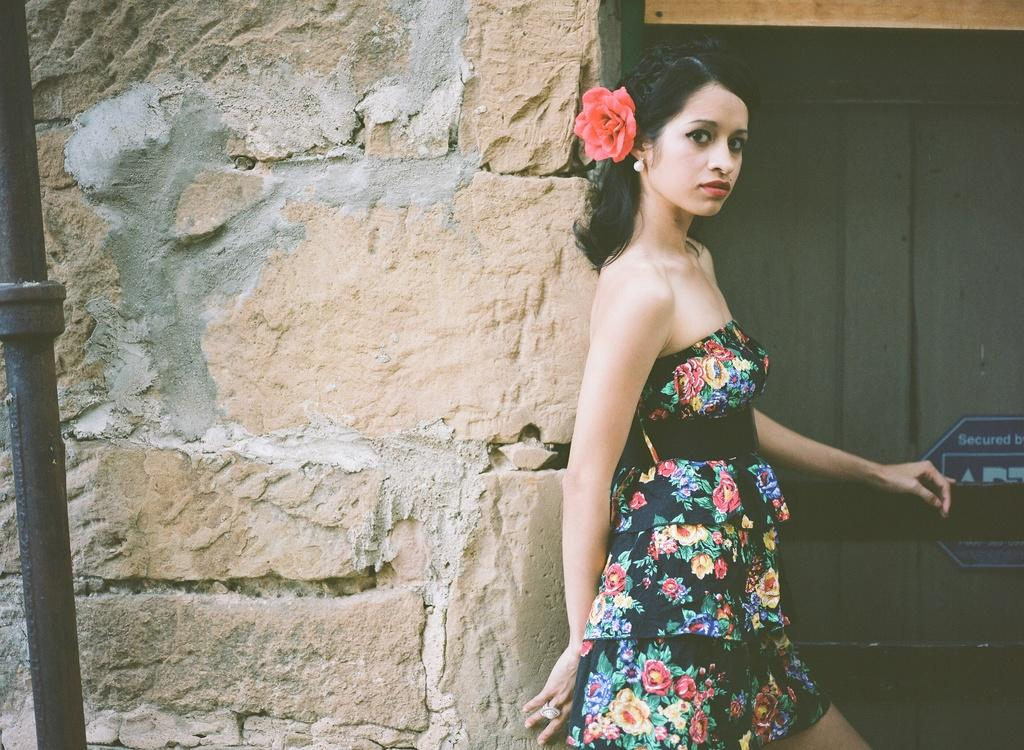Who is present in the image? There is a woman in the image. What is the woman's position in relation to the wall? The woman is standing near a wall in the image. What type of wooden object can be seen in the image? There is a wooden object that resembles a door in the image. What is attached to the wooden object? A board is attached to the wooden object in the image. Can you tell me how many islands are visible in the image? There are no islands present in the image; it features a woman standing near a wall with a wooden object that resembles a door. What type of lamp is hanging from the rod in the image? There is no lamp or rod present in the image. 